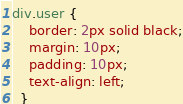Convert code to text. <code><loc_0><loc_0><loc_500><loc_500><_CSS_>div.user {
    border: 2px solid black;
    margin: 10px;
    padding: 10px;
    text-align: left;
  }</code> 